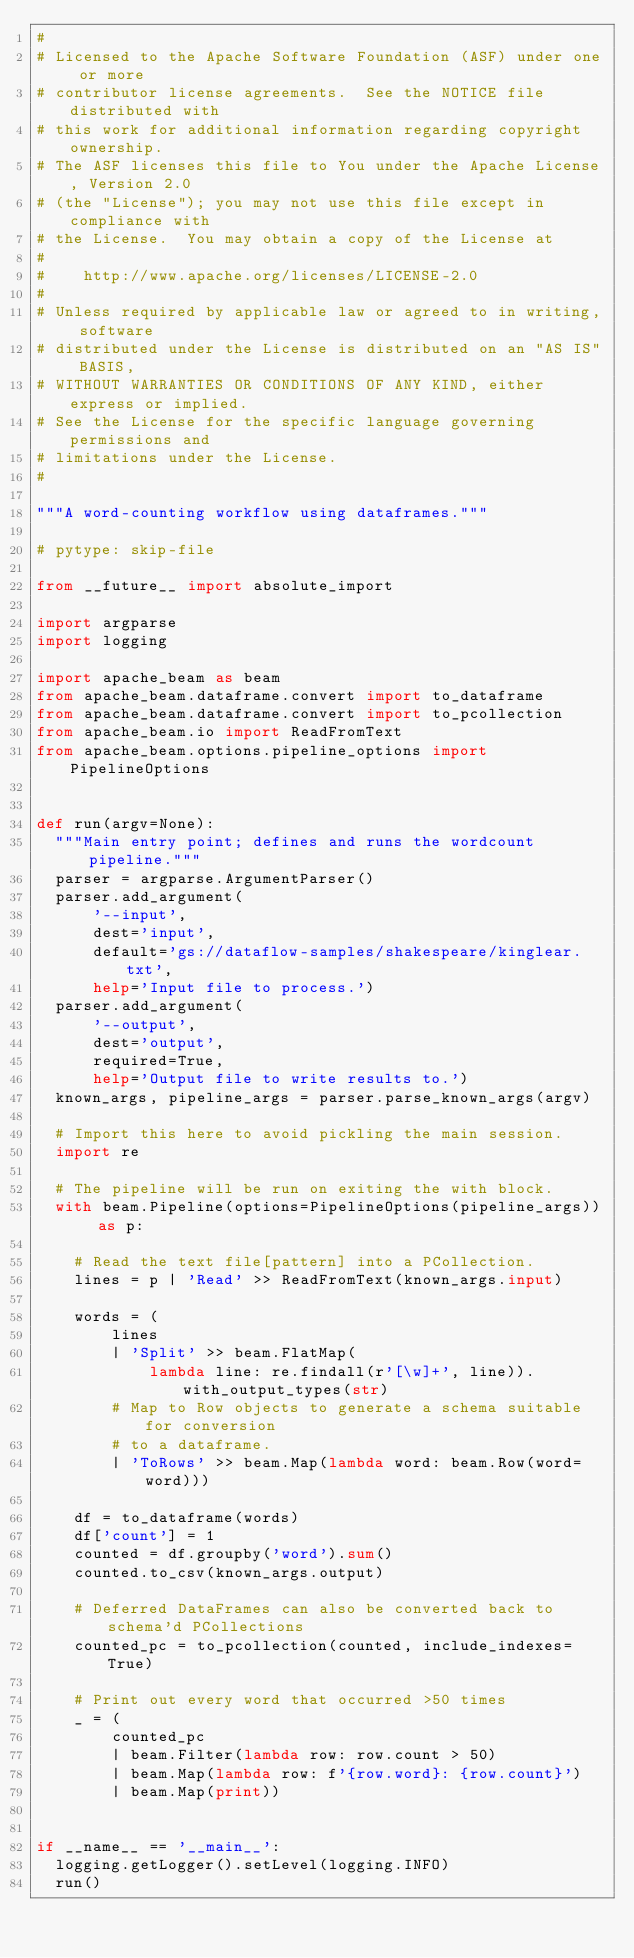Convert code to text. <code><loc_0><loc_0><loc_500><loc_500><_Python_>#
# Licensed to the Apache Software Foundation (ASF) under one or more
# contributor license agreements.  See the NOTICE file distributed with
# this work for additional information regarding copyright ownership.
# The ASF licenses this file to You under the Apache License, Version 2.0
# (the "License"); you may not use this file except in compliance with
# the License.  You may obtain a copy of the License at
#
#    http://www.apache.org/licenses/LICENSE-2.0
#
# Unless required by applicable law or agreed to in writing, software
# distributed under the License is distributed on an "AS IS" BASIS,
# WITHOUT WARRANTIES OR CONDITIONS OF ANY KIND, either express or implied.
# See the License for the specific language governing permissions and
# limitations under the License.
#

"""A word-counting workflow using dataframes."""

# pytype: skip-file

from __future__ import absolute_import

import argparse
import logging

import apache_beam as beam
from apache_beam.dataframe.convert import to_dataframe
from apache_beam.dataframe.convert import to_pcollection
from apache_beam.io import ReadFromText
from apache_beam.options.pipeline_options import PipelineOptions


def run(argv=None):
  """Main entry point; defines and runs the wordcount pipeline."""
  parser = argparse.ArgumentParser()
  parser.add_argument(
      '--input',
      dest='input',
      default='gs://dataflow-samples/shakespeare/kinglear.txt',
      help='Input file to process.')
  parser.add_argument(
      '--output',
      dest='output',
      required=True,
      help='Output file to write results to.')
  known_args, pipeline_args = parser.parse_known_args(argv)

  # Import this here to avoid pickling the main session.
  import re

  # The pipeline will be run on exiting the with block.
  with beam.Pipeline(options=PipelineOptions(pipeline_args)) as p:

    # Read the text file[pattern] into a PCollection.
    lines = p | 'Read' >> ReadFromText(known_args.input)

    words = (
        lines
        | 'Split' >> beam.FlatMap(
            lambda line: re.findall(r'[\w]+', line)).with_output_types(str)
        # Map to Row objects to generate a schema suitable for conversion
        # to a dataframe.
        | 'ToRows' >> beam.Map(lambda word: beam.Row(word=word)))

    df = to_dataframe(words)
    df['count'] = 1
    counted = df.groupby('word').sum()
    counted.to_csv(known_args.output)

    # Deferred DataFrames can also be converted back to schema'd PCollections
    counted_pc = to_pcollection(counted, include_indexes=True)

    # Print out every word that occurred >50 times
    _ = (
        counted_pc
        | beam.Filter(lambda row: row.count > 50)
        | beam.Map(lambda row: f'{row.word}: {row.count}')
        | beam.Map(print))


if __name__ == '__main__':
  logging.getLogger().setLevel(logging.INFO)
  run()
</code> 